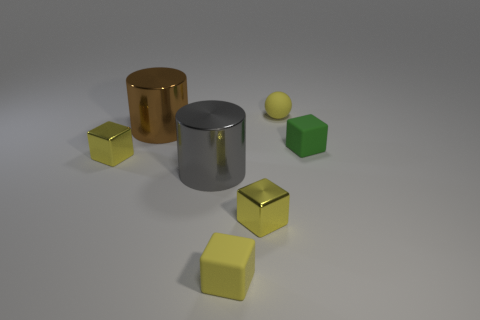How many rubber blocks are there?
Your answer should be very brief. 2. How many matte objects are small yellow cubes or big brown things?
Provide a succinct answer. 1. How many rubber blocks are the same color as the small ball?
Offer a terse response. 1. The small cube on the right side of the small yellow metallic thing right of the gray thing is made of what material?
Offer a very short reply. Rubber. The yellow rubber block is what size?
Keep it short and to the point. Small. How many yellow rubber objects have the same size as the ball?
Ensure brevity in your answer.  1. How many yellow things are the same shape as the green rubber thing?
Keep it short and to the point. 3. Are there an equal number of small green matte things to the left of the green matte object and green matte objects?
Your response must be concise. No. Are there any other things that have the same size as the green rubber block?
Provide a succinct answer. Yes. What shape is the green rubber thing that is the same size as the yellow rubber ball?
Ensure brevity in your answer.  Cube. 